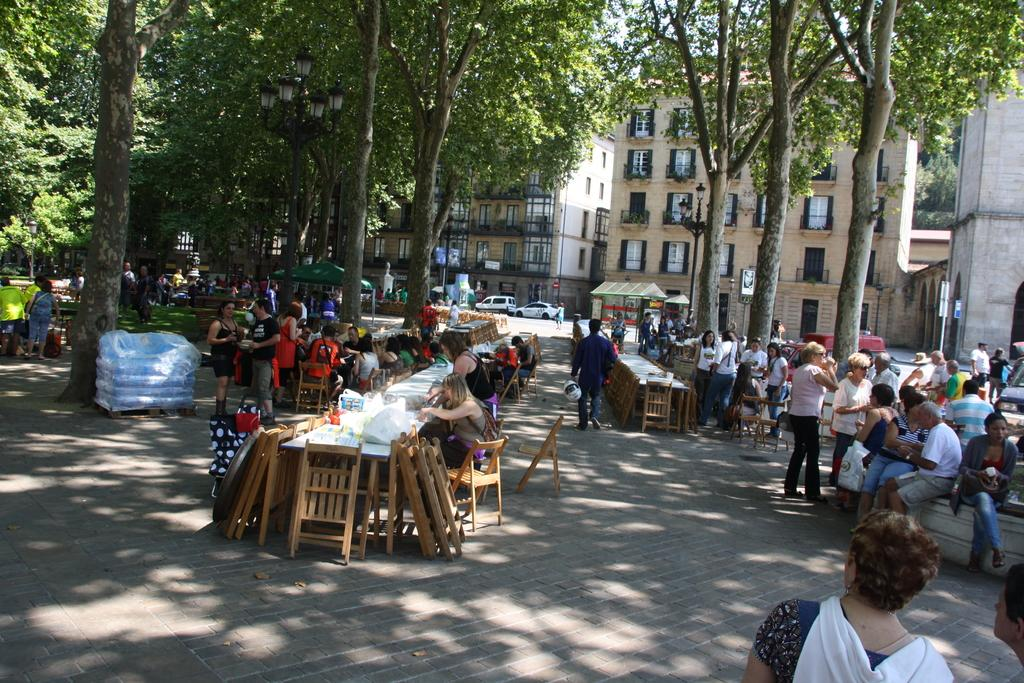What are the people in the image doing? There are people sitting on chairs and standing on the road in the image. What can be seen in the background of the image? There are trees and buildings visible in the background of the image. How many dogs are present in the image? There are no dogs visible in the image. What fact can be determined about the things in the image? The question is unclear and does not relate to any specific fact about the image. The image contains people, chairs, a road, trees, and buildings, but there is no specific "fact" about these things that can be determined without additional context or information. 